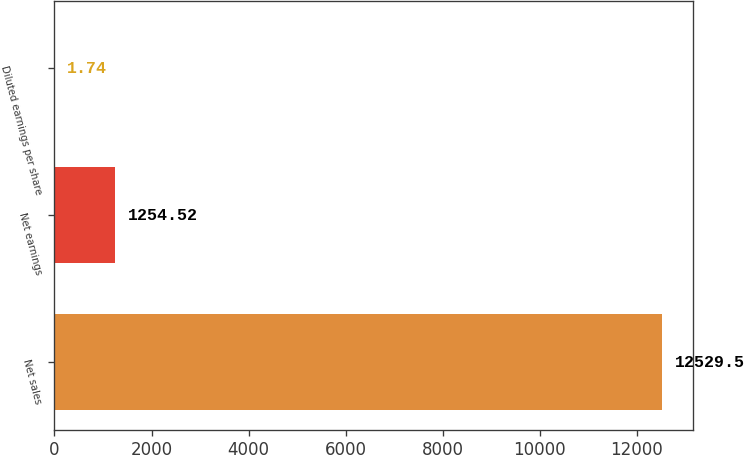<chart> <loc_0><loc_0><loc_500><loc_500><bar_chart><fcel>Net sales<fcel>Net earnings<fcel>Diluted earnings per share<nl><fcel>12529.5<fcel>1254.52<fcel>1.74<nl></chart> 